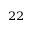Convert formula to latex. <formula><loc_0><loc_0><loc_500><loc_500>^ { 2 2 }</formula> 